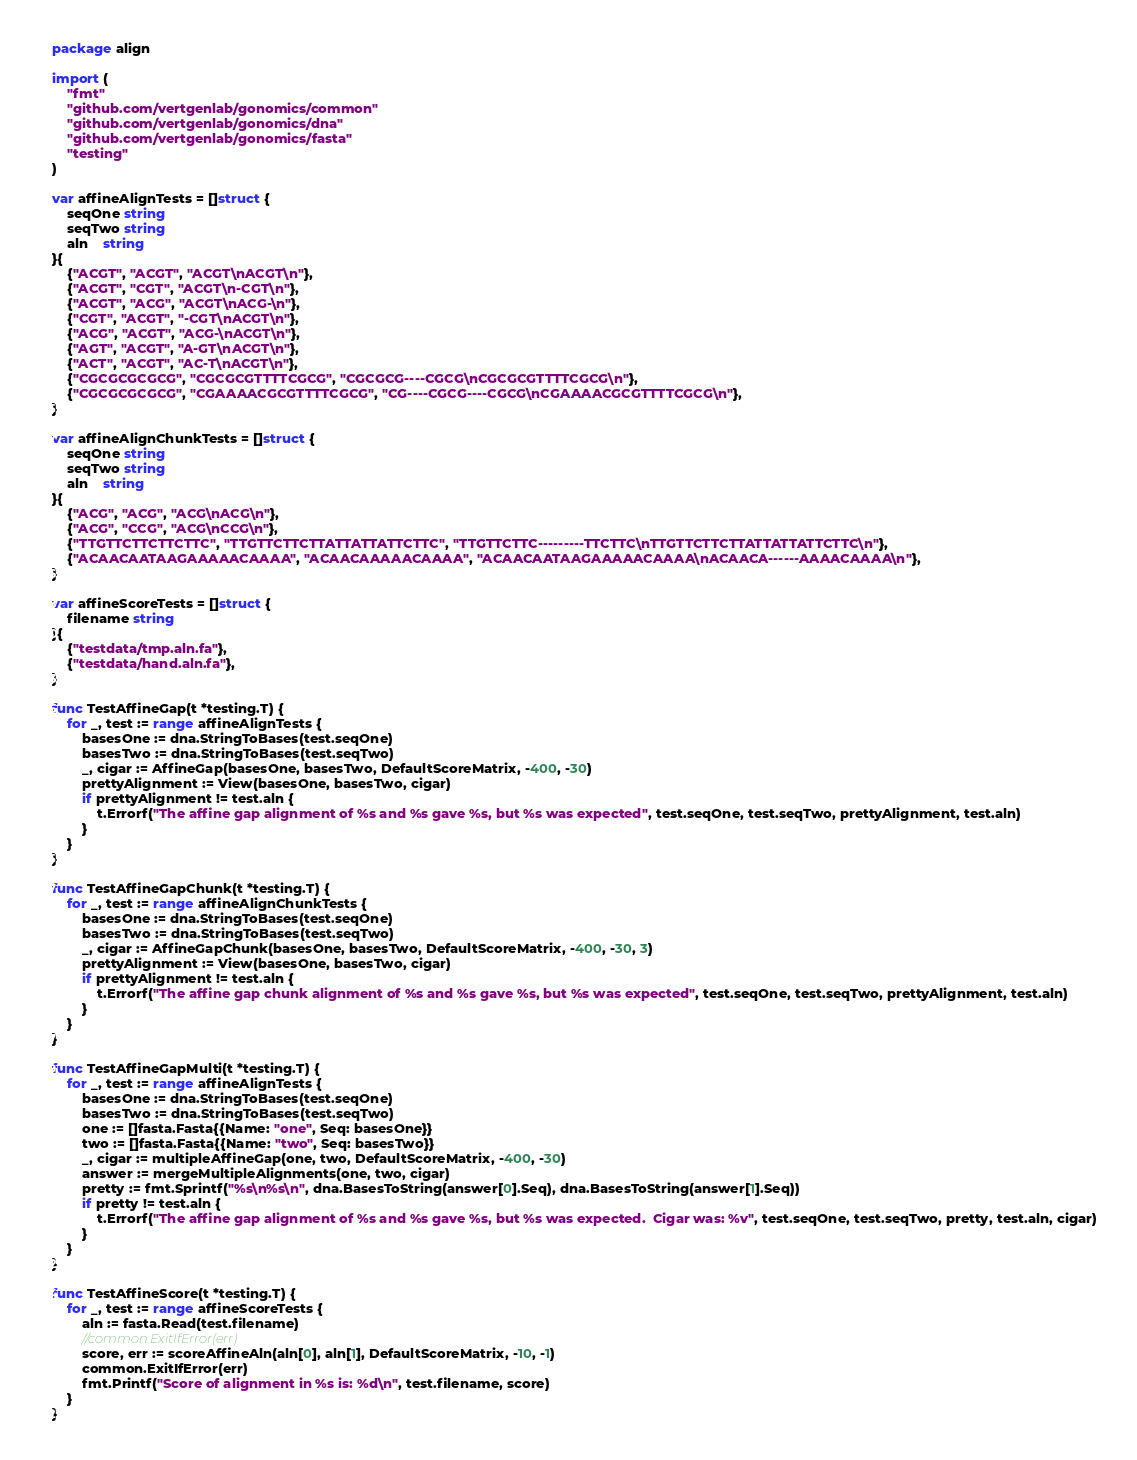<code> <loc_0><loc_0><loc_500><loc_500><_Go_>package align

import (
	"fmt"
	"github.com/vertgenlab/gonomics/common"
	"github.com/vertgenlab/gonomics/dna"
	"github.com/vertgenlab/gonomics/fasta"
	"testing"
)

var affineAlignTests = []struct {
	seqOne string
	seqTwo string
	aln    string
}{
	{"ACGT", "ACGT", "ACGT\nACGT\n"},
	{"ACGT", "CGT", "ACGT\n-CGT\n"},
	{"ACGT", "ACG", "ACGT\nACG-\n"},
	{"CGT", "ACGT", "-CGT\nACGT\n"},
	{"ACG", "ACGT", "ACG-\nACGT\n"},
	{"AGT", "ACGT", "A-GT\nACGT\n"},
	{"ACT", "ACGT", "AC-T\nACGT\n"},
	{"CGCGCGCGCG", "CGCGCGTTTTCGCG", "CGCGCG----CGCG\nCGCGCGTTTTCGCG\n"},
	{"CGCGCGCGCG", "CGAAAACGCGTTTTCGCG", "CG----CGCG----CGCG\nCGAAAACGCGTTTTCGCG\n"},
}

var affineAlignChunkTests = []struct {
	seqOne string
	seqTwo string
	aln    string
}{
	{"ACG", "ACG", "ACG\nACG\n"},
	{"ACG", "CCG", "ACG\nCCG\n"},
	{"TTGTTCTTCTTCTTC", "TTGTTCTTCTTATTATTATTCTTC", "TTGTTCTTC---------TTCTTC\nTTGTTCTTCTTATTATTATTCTTC\n"},
	{"ACAACAATAAGAAAAACAAAA", "ACAACAAAAACAAAA", "ACAACAATAAGAAAAACAAAA\nACAACA------AAAACAAAA\n"},
}

var affineScoreTests = []struct {
	filename string
}{
	{"testdata/tmp.aln.fa"},
	{"testdata/hand.aln.fa"},
}

func TestAffineGap(t *testing.T) {
	for _, test := range affineAlignTests {
		basesOne := dna.StringToBases(test.seqOne)
		basesTwo := dna.StringToBases(test.seqTwo)
		_, cigar := AffineGap(basesOne, basesTwo, DefaultScoreMatrix, -400, -30)
		prettyAlignment := View(basesOne, basesTwo, cigar)
		if prettyAlignment != test.aln {
			t.Errorf("The affine gap alignment of %s and %s gave %s, but %s was expected", test.seqOne, test.seqTwo, prettyAlignment, test.aln)
		}
	}
}

func TestAffineGapChunk(t *testing.T) {
	for _, test := range affineAlignChunkTests {
		basesOne := dna.StringToBases(test.seqOne)
		basesTwo := dna.StringToBases(test.seqTwo)
		_, cigar := AffineGapChunk(basesOne, basesTwo, DefaultScoreMatrix, -400, -30, 3)
		prettyAlignment := View(basesOne, basesTwo, cigar)
		if prettyAlignment != test.aln {
			t.Errorf("The affine gap chunk alignment of %s and %s gave %s, but %s was expected", test.seqOne, test.seqTwo, prettyAlignment, test.aln)
		}
	}
}

func TestAffineGapMulti(t *testing.T) {
	for _, test := range affineAlignTests {
		basesOne := dna.StringToBases(test.seqOne)
		basesTwo := dna.StringToBases(test.seqTwo)
		one := []fasta.Fasta{{Name: "one", Seq: basesOne}}
		two := []fasta.Fasta{{Name: "two", Seq: basesTwo}}
		_, cigar := multipleAffineGap(one, two, DefaultScoreMatrix, -400, -30)
		answer := mergeMultipleAlignments(one, two, cigar)
		pretty := fmt.Sprintf("%s\n%s\n", dna.BasesToString(answer[0].Seq), dna.BasesToString(answer[1].Seq))
		if pretty != test.aln {
			t.Errorf("The affine gap alignment of %s and %s gave %s, but %s was expected.  Cigar was: %v", test.seqOne, test.seqTwo, pretty, test.aln, cigar)
		}
	}
}

func TestAffineScore(t *testing.T) {
	for _, test := range affineScoreTests {
		aln := fasta.Read(test.filename)
		//common.ExitIfError(err)
		score, err := scoreAffineAln(aln[0], aln[1], DefaultScoreMatrix, -10, -1)
		common.ExitIfError(err)
		fmt.Printf("Score of alignment in %s is: %d\n", test.filename, score)
	}
}
</code> 